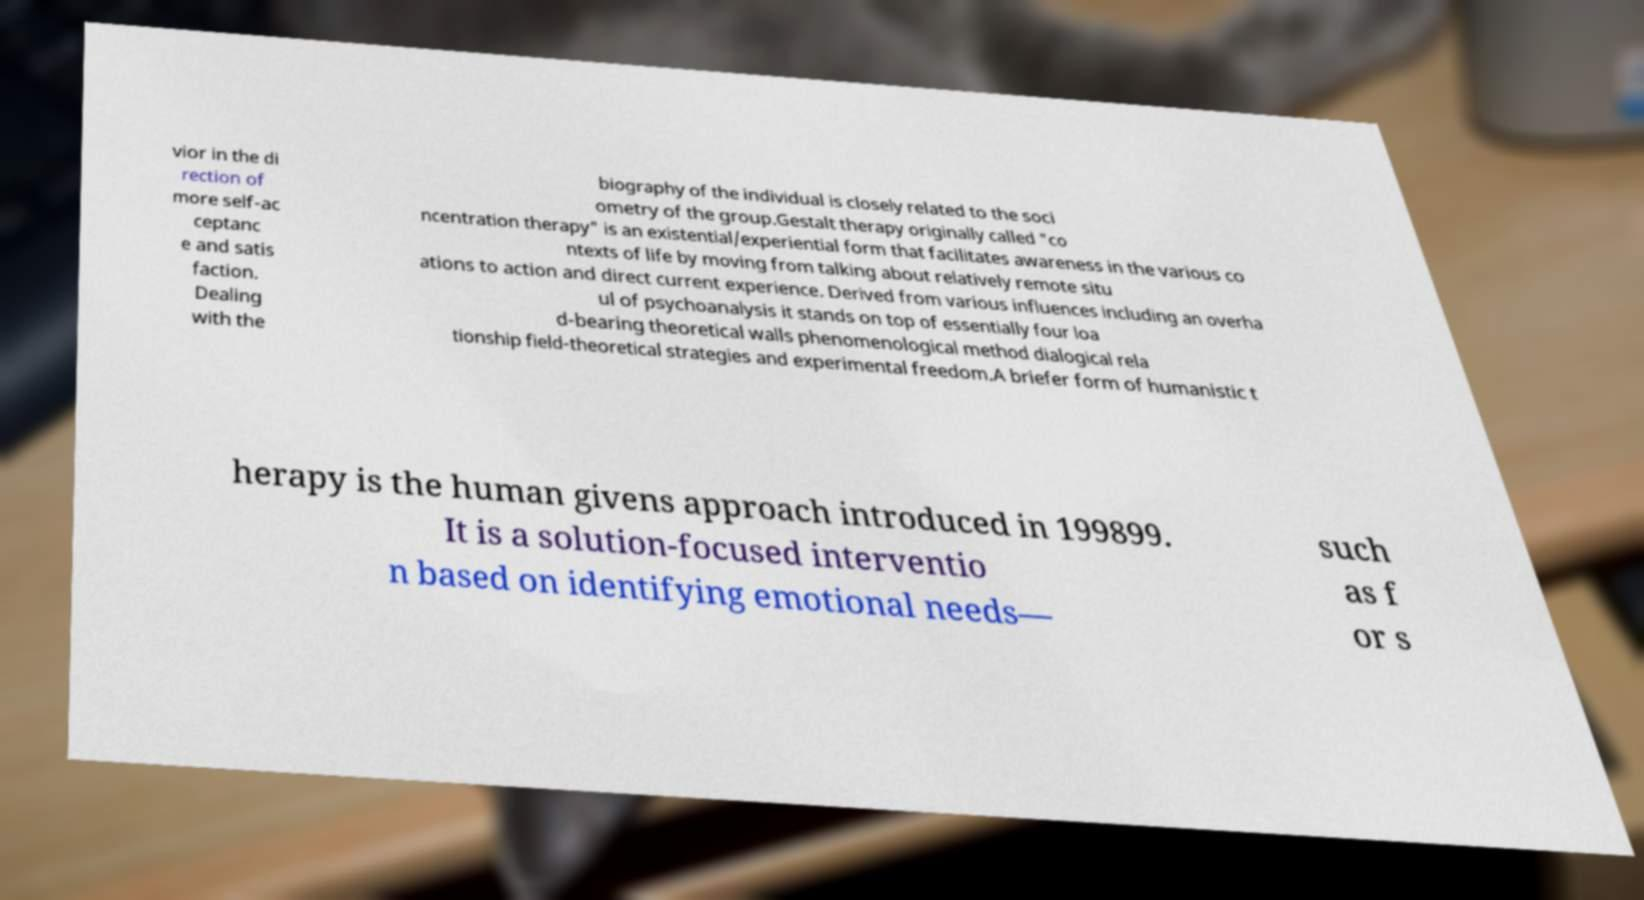Could you assist in decoding the text presented in this image and type it out clearly? vior in the di rection of more self-ac ceptanc e and satis faction. Dealing with the biography of the individual is closely related to the soci ometry of the group.Gestalt therapy originally called "co ncentration therapy" is an existential/experiential form that facilitates awareness in the various co ntexts of life by moving from talking about relatively remote situ ations to action and direct current experience. Derived from various influences including an overha ul of psychoanalysis it stands on top of essentially four loa d-bearing theoretical walls phenomenological method dialogical rela tionship field-theoretical strategies and experimental freedom.A briefer form of humanistic t herapy is the human givens approach introduced in 199899. It is a solution-focused interventio n based on identifying emotional needs— such as f or s 